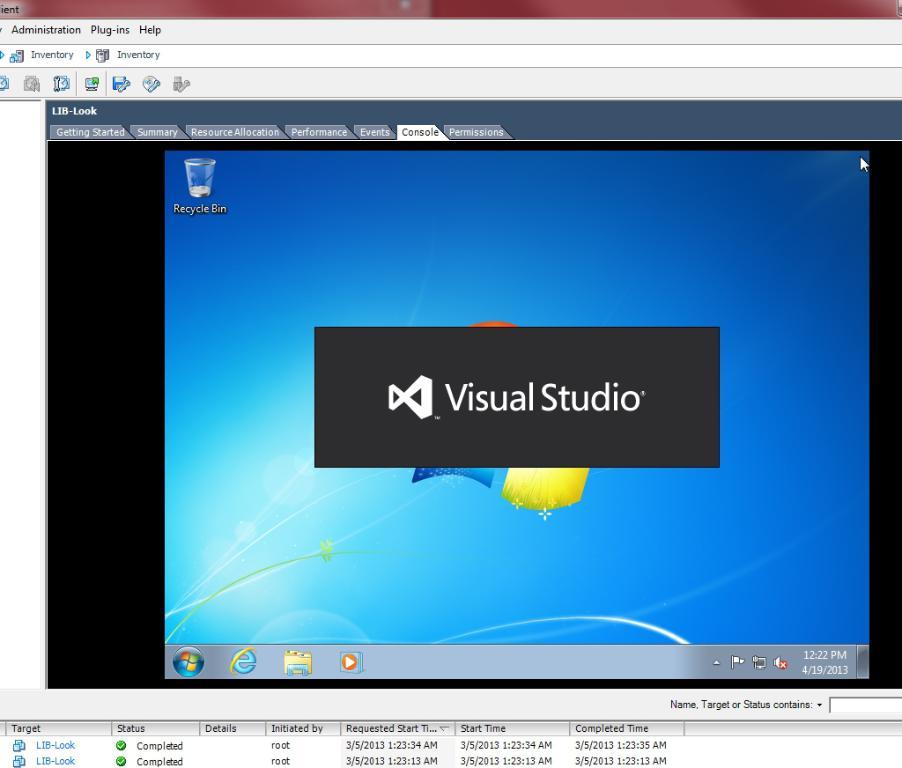<image>
Describe the image concisely. A program called Visual Studio is opening up on a computer 